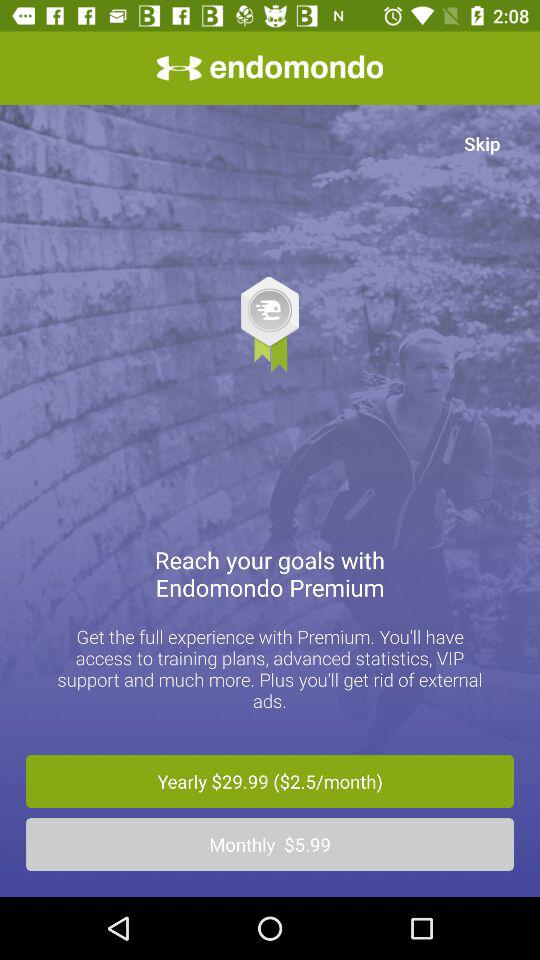Which are the different plans? The different plans are $29.99 per year ($2.5 per month) and $5.99 per month. 